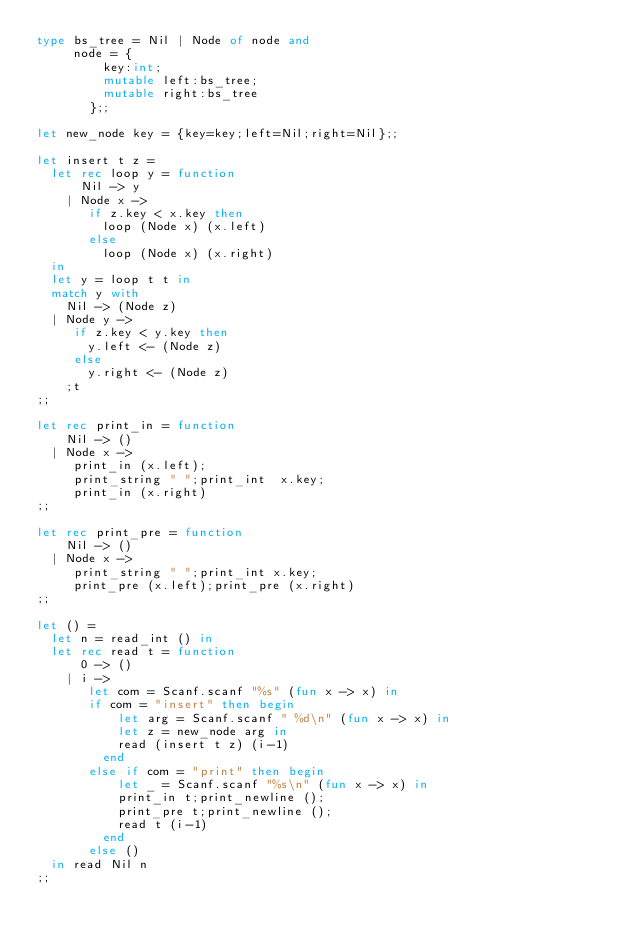Convert code to text. <code><loc_0><loc_0><loc_500><loc_500><_OCaml_>type bs_tree = Nil | Node of node and
     node = {
         key:int;
         mutable left:bs_tree;
         mutable right:bs_tree
       };;

let new_node key = {key=key;left=Nil;right=Nil};;

let insert t z =
  let rec loop y = function
      Nil -> y
    | Node x ->
       if z.key < x.key then
         loop (Node x) (x.left)
       else
         loop (Node x) (x.right)
  in
  let y = loop t t in
  match y with
    Nil -> (Node z)
  | Node y ->
     if z.key < y.key then
       y.left <- (Node z)
     else
       y.right <- (Node z)
    ;t
;;

let rec print_in = function
    Nil -> ()
  | Node x ->
     print_in (x.left);
     print_string " ";print_int  x.key;
     print_in (x.right)
;;

let rec print_pre = function
    Nil -> ()
  | Node x ->
     print_string " ";print_int x.key;
     print_pre (x.left);print_pre (x.right)
;;

let () =
  let n = read_int () in
  let rec read t = function
      0 -> ()
    | i ->
       let com = Scanf.scanf "%s" (fun x -> x) in
       if com = "insert" then begin
           let arg = Scanf.scanf " %d\n" (fun x -> x) in
           let z = new_node arg in
           read (insert t z) (i-1)
         end
       else if com = "print" then begin
           let _ = Scanf.scanf "%s\n" (fun x -> x) in
           print_in t;print_newline ();
           print_pre t;print_newline ();
           read t (i-1)
         end
       else ()
  in read Nil n
;;</code> 